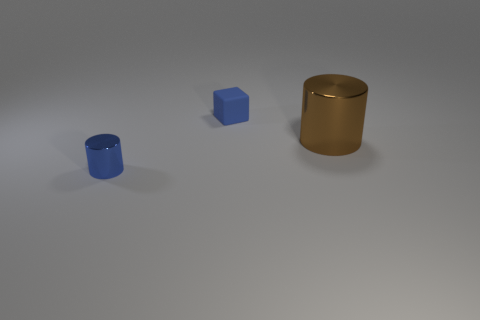Add 2 large objects. How many objects exist? 5 Subtract all blocks. How many objects are left? 2 Subtract all matte blocks. Subtract all small things. How many objects are left? 0 Add 3 big brown things. How many big brown things are left? 4 Add 1 gray matte blocks. How many gray matte blocks exist? 1 Subtract 0 red blocks. How many objects are left? 3 